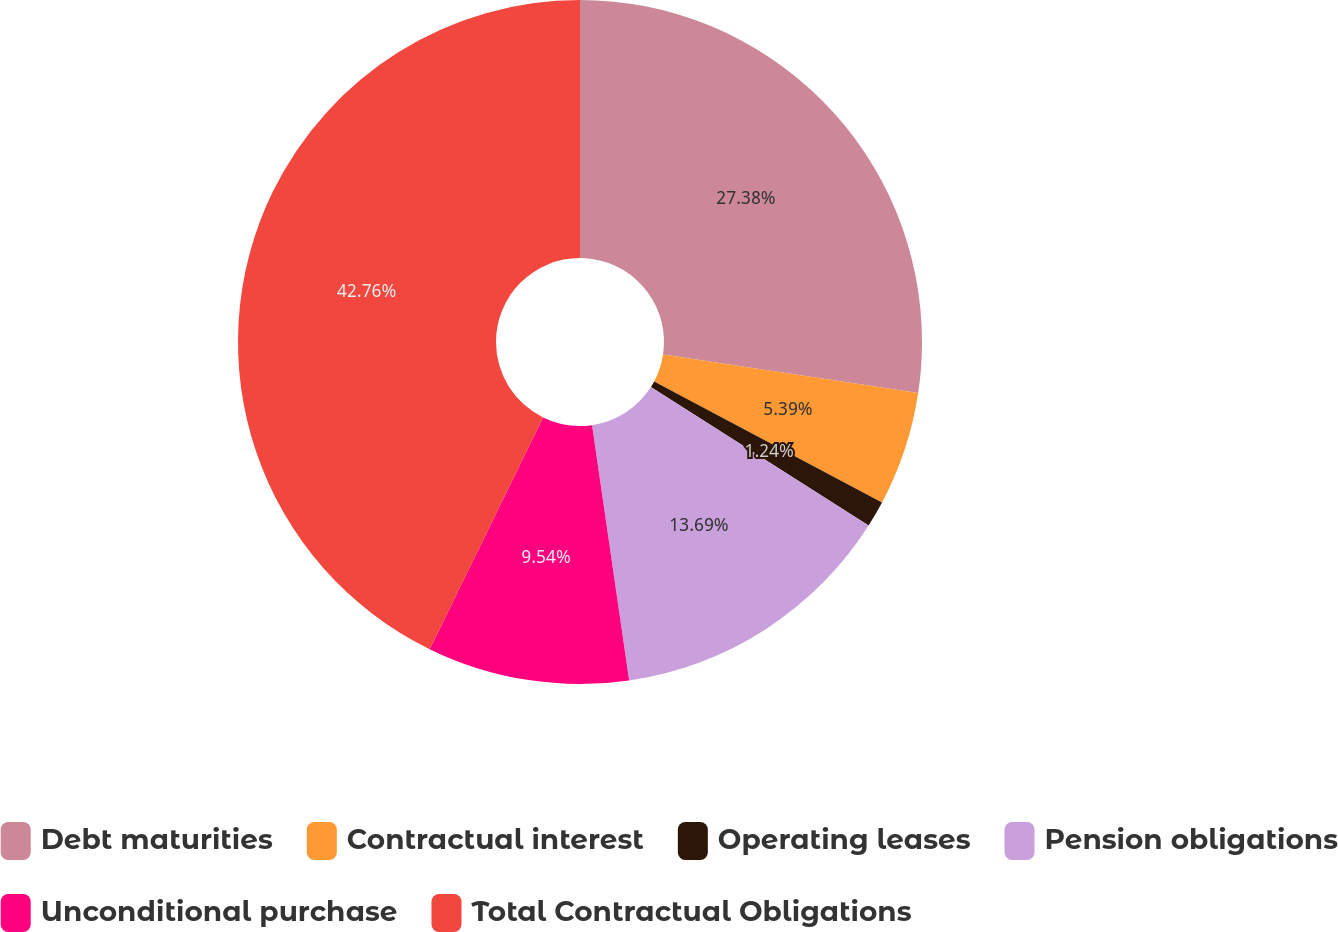Convert chart. <chart><loc_0><loc_0><loc_500><loc_500><pie_chart><fcel>Debt maturities<fcel>Contractual interest<fcel>Operating leases<fcel>Pension obligations<fcel>Unconditional purchase<fcel>Total Contractual Obligations<nl><fcel>27.38%<fcel>5.39%<fcel>1.24%<fcel>13.69%<fcel>9.54%<fcel>42.75%<nl></chart> 